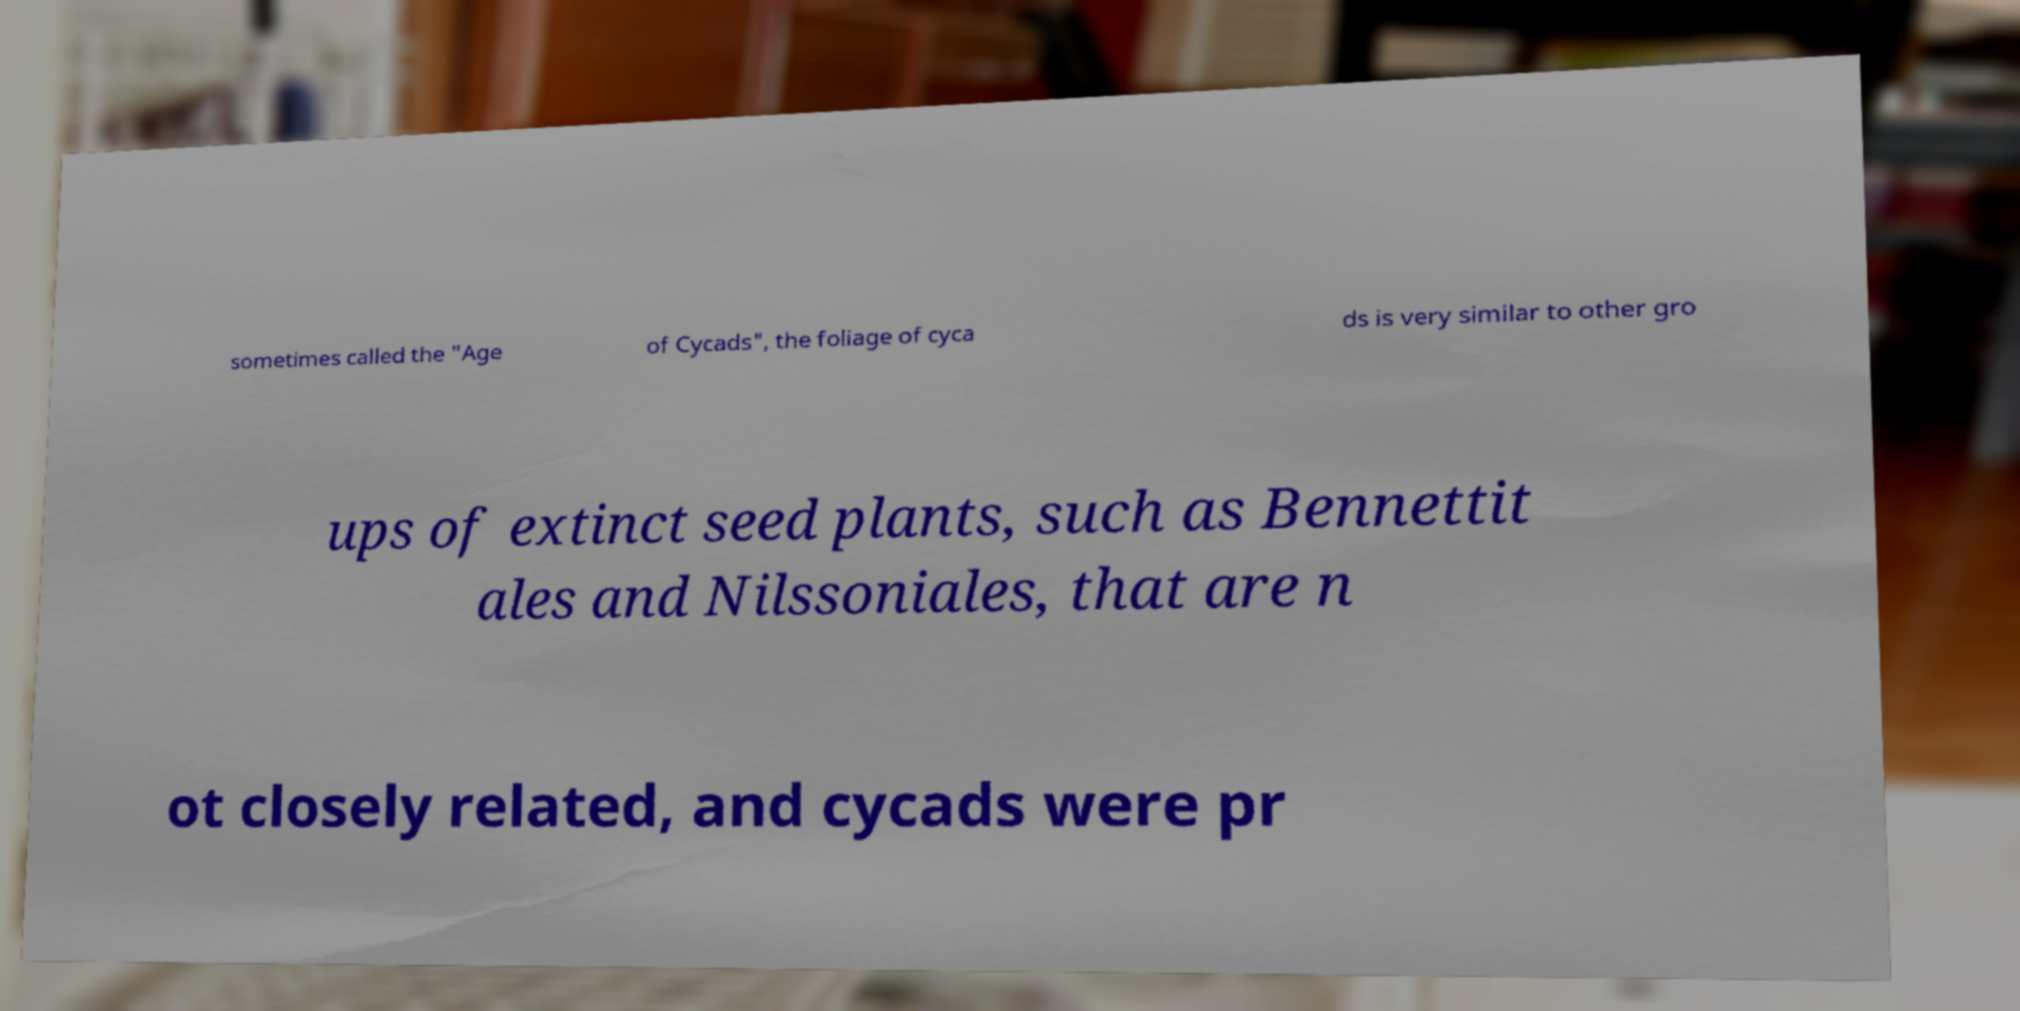There's text embedded in this image that I need extracted. Can you transcribe it verbatim? sometimes called the "Age of Cycads", the foliage of cyca ds is very similar to other gro ups of extinct seed plants, such as Bennettit ales and Nilssoniales, that are n ot closely related, and cycads were pr 